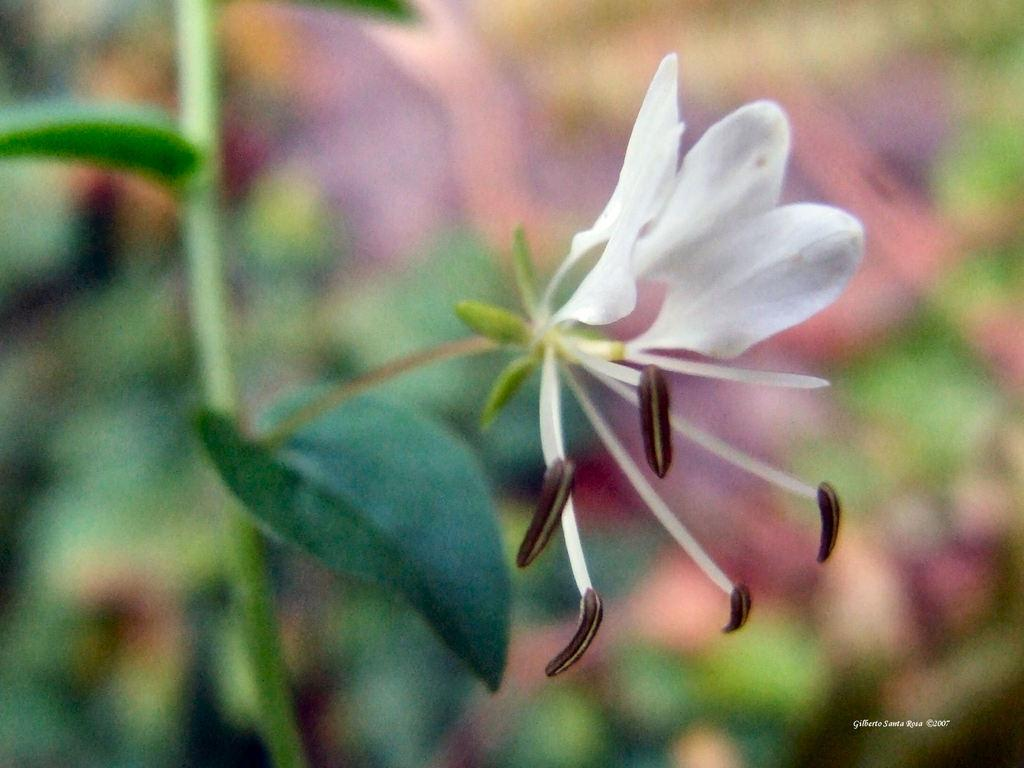What is the main subject of the image? There is a flower in the image. What parts of the flower are visible? There are leaves and a stem in the image. How would you describe the background of the image? The background of the image is blurred. Is there any additional information or markings on the image? There is a watermark on the image. What type of quiet tiger can be seen in the image? There is no tiger present in the image; it features a flower with leaves and a stem. What caption is written on the image? There is no caption visible in the image; it only contains a flower, leaves, stem, and a blurred background with a watermark. 